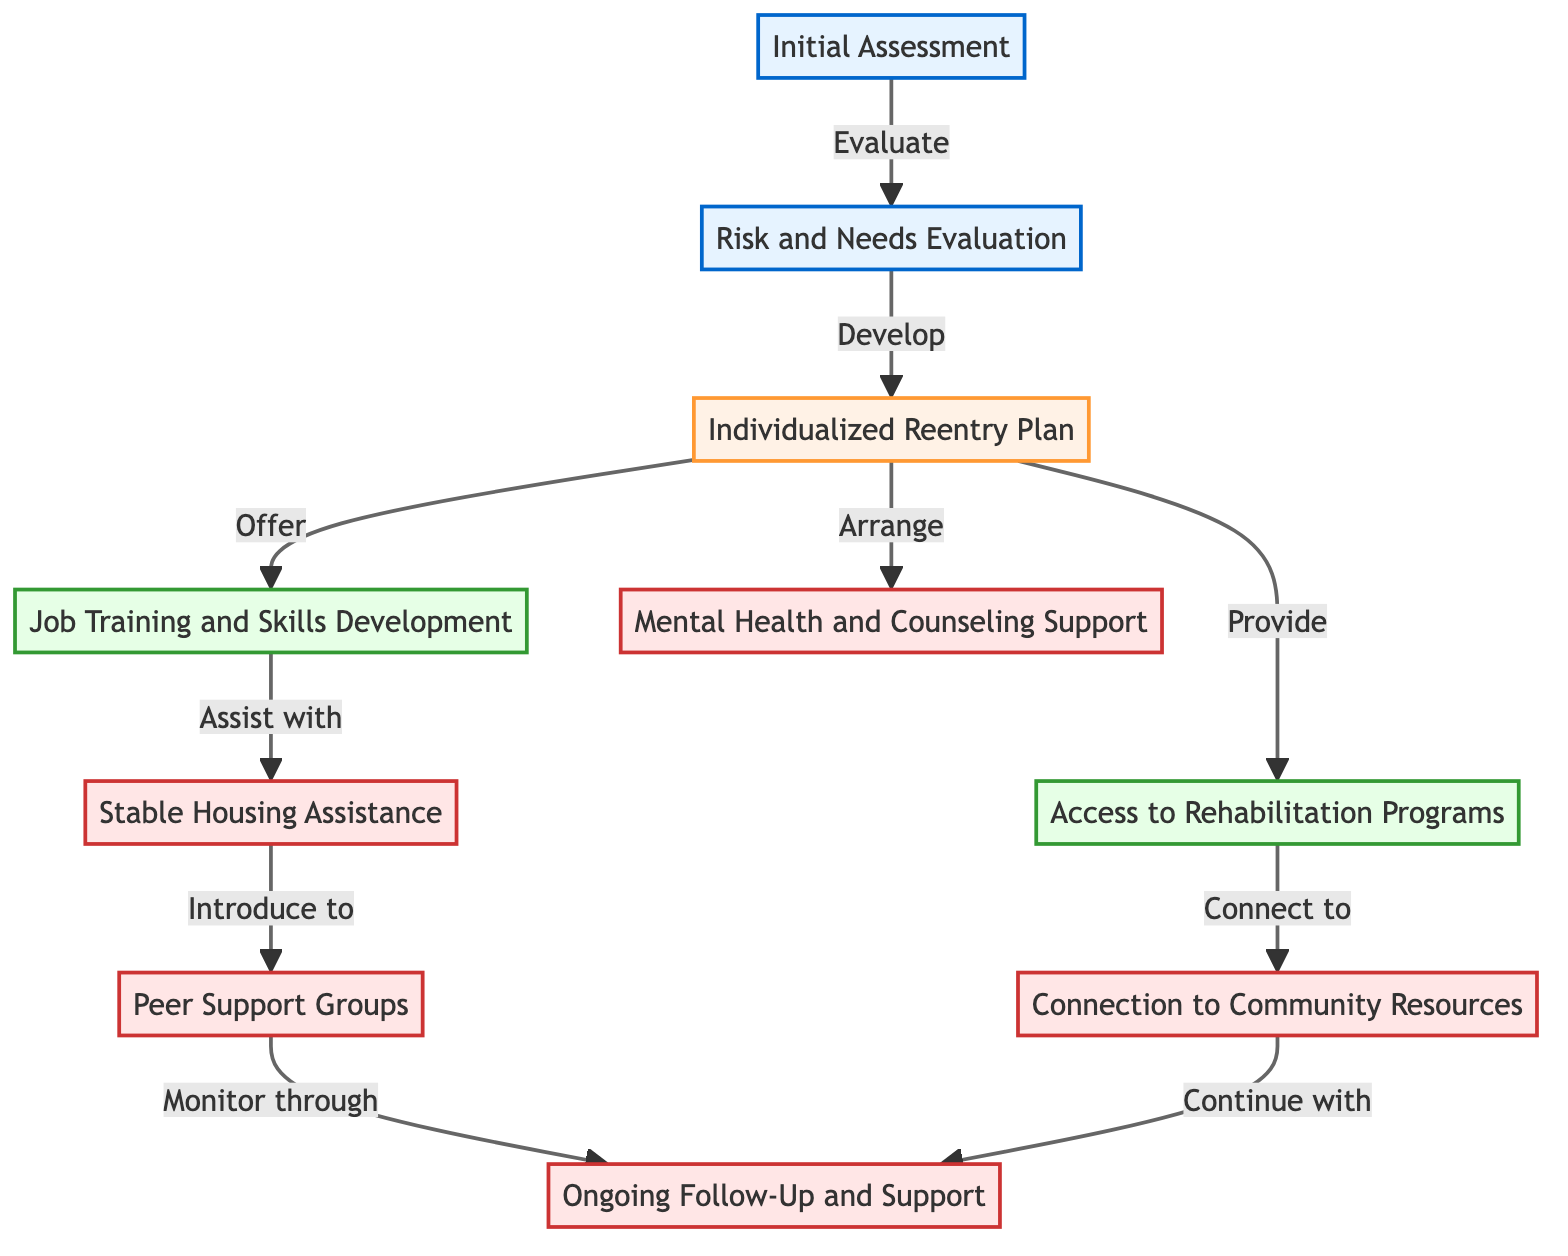What is the first step in the reentry process? The first step is identified as "Initial Assessment" in the diagram. It is depicted as the starting node, meaning that it is the first action completed in the reentry process.
Answer: Initial Assessment How many nodes are there in this diagram? To determine the number of nodes, we count each individual node present in the diagram. There are ten nodes listed in the data provided.
Answer: 10 Which node does the "Risk and Needs Evaluation" lead to? The "Risk and Needs Evaluation" leads to the node representing the "Individualized Reentry Plan". This is confirmed by the directed edge indicating the relationship between these two nodes.
Answer: Individualized Reentry Plan What follows after "Access to Rehabilitation Programs"? After "Access to Rehabilitation Programs", the next node is "Connection to Community Resources". There is a directed edge that connects these two nodes, showing the sequential flow.
Answer: Connection to Community Resources Which support is introduced after "Stable Housing Assistance"? Following "Stable Housing Assistance", the diagram indicates that it leads to "Peer Support Groups". This can be seen through the directed edge connecting Stable Housing Assistance to Peer Support Groups.
Answer: Peer Support Groups How many edges are there in the diagram? To find the number of edges, we look at the connections made between the nodes. The diagram provides a total of ten edges as outlined in the provided data.
Answer: 10 Which program directly assists with job training? The node representing "Job Training and Skills Development" directly follows from the "Individualized Reentry Plan". This indicates that it is one of the programs that can be accessed in conjunction with the plan.
Answer: Job Training and Skills Development What is the last step that includes ongoing support? The last step that includes ongoing support is captured by the "Ongoing Follow-Up and Support" node. This node is reached through directed edges from both "Peer Support Groups" and "Connection to Community Resources".
Answer: Ongoing Follow-Up and Support 